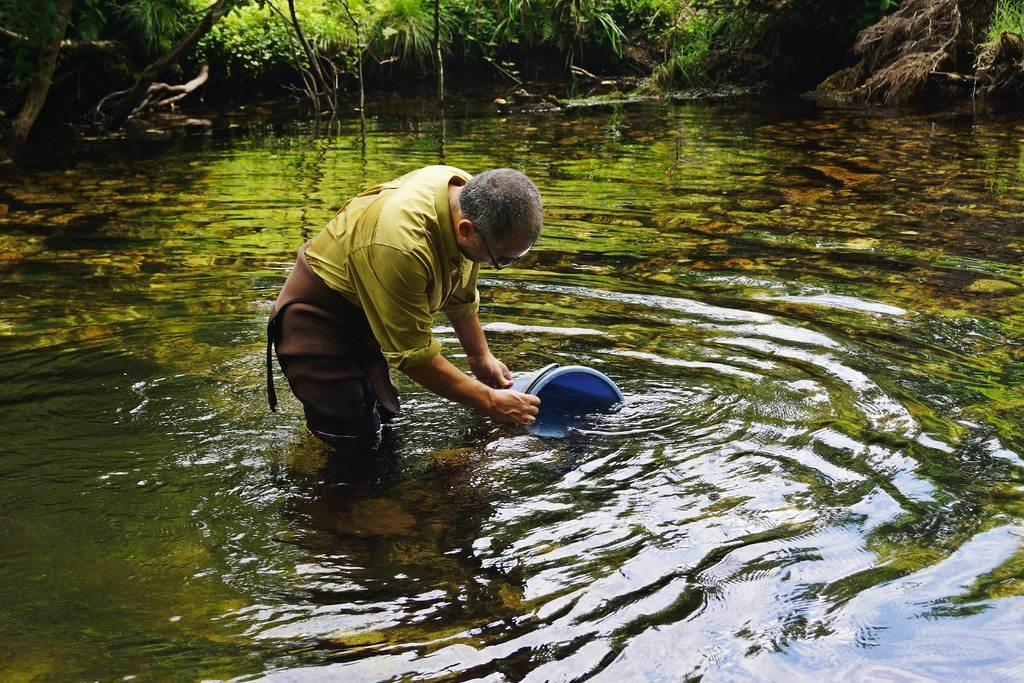What is the man in the image doing? The man is in the water in the image. What is the man holding in the image? The man is holding a blue color bucket. What can be seen in the background of the image? There are trees visible on the side of the lake at the top of the image. What type of nut can be seen on the edge of the lake in the image? There is no nut visible on the edge of the lake in the image. 